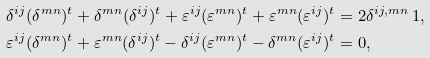<formula> <loc_0><loc_0><loc_500><loc_500>\delta ^ { i j } ( \delta ^ { m n } ) ^ { t } + \delta ^ { m n } ( \delta ^ { i j } ) ^ { t } + \varepsilon ^ { i j } ( \varepsilon ^ { m n } ) ^ { t } + \varepsilon ^ { m n } ( \varepsilon ^ { i j } ) ^ { t } & = 2 \delta ^ { i j , m n } \, 1 , \\ \varepsilon ^ { i j } ( \delta ^ { m n } ) ^ { t } + \varepsilon ^ { m n } ( \delta ^ { i j } ) ^ { t } - \delta ^ { i j } ( \varepsilon ^ { m n } ) ^ { t } - \delta ^ { m n } ( \varepsilon ^ { i j } ) ^ { t } & = 0 ,</formula> 